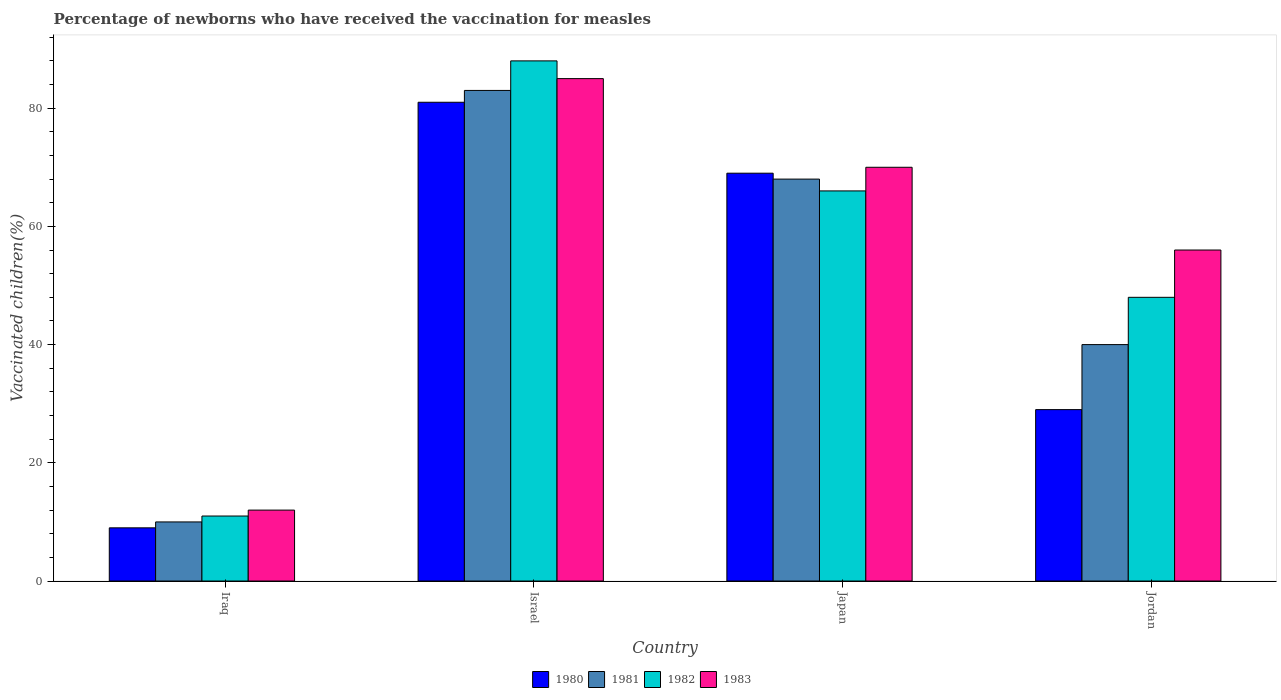How many different coloured bars are there?
Offer a very short reply. 4. How many groups of bars are there?
Your answer should be very brief. 4. Are the number of bars on each tick of the X-axis equal?
Give a very brief answer. Yes. In how many cases, is the number of bars for a given country not equal to the number of legend labels?
Provide a succinct answer. 0. In which country was the percentage of vaccinated children in 1983 maximum?
Your response must be concise. Israel. In which country was the percentage of vaccinated children in 1982 minimum?
Offer a terse response. Iraq. What is the total percentage of vaccinated children in 1981 in the graph?
Keep it short and to the point. 201. What is the average percentage of vaccinated children in 1983 per country?
Ensure brevity in your answer.  55.75. What is the difference between the percentage of vaccinated children of/in 1982 and percentage of vaccinated children of/in 1980 in Japan?
Provide a short and direct response. -3. What is the ratio of the percentage of vaccinated children in 1982 in Iraq to that in Israel?
Ensure brevity in your answer.  0.12. What is the difference between the highest and the lowest percentage of vaccinated children in 1980?
Provide a short and direct response. 72. In how many countries, is the percentage of vaccinated children in 1983 greater than the average percentage of vaccinated children in 1983 taken over all countries?
Your answer should be very brief. 3. Is it the case that in every country, the sum of the percentage of vaccinated children in 1983 and percentage of vaccinated children in 1982 is greater than the sum of percentage of vaccinated children in 1981 and percentage of vaccinated children in 1980?
Give a very brief answer. No. What does the 4th bar from the right in Israel represents?
Provide a succinct answer. 1980. Where does the legend appear in the graph?
Make the answer very short. Bottom center. How many legend labels are there?
Give a very brief answer. 4. How are the legend labels stacked?
Provide a short and direct response. Horizontal. What is the title of the graph?
Provide a succinct answer. Percentage of newborns who have received the vaccination for measles. Does "2003" appear as one of the legend labels in the graph?
Provide a succinct answer. No. What is the label or title of the X-axis?
Provide a succinct answer. Country. What is the label or title of the Y-axis?
Offer a very short reply. Vaccinated children(%). What is the Vaccinated children(%) of 1980 in Iraq?
Your answer should be compact. 9. What is the Vaccinated children(%) in 1982 in Iraq?
Make the answer very short. 11. What is the Vaccinated children(%) in 1983 in Iraq?
Offer a terse response. 12. What is the Vaccinated children(%) in 1980 in Israel?
Keep it short and to the point. 81. What is the Vaccinated children(%) of 1981 in Israel?
Give a very brief answer. 83. What is the Vaccinated children(%) of 1980 in Japan?
Make the answer very short. 69. What is the Vaccinated children(%) of 1980 in Jordan?
Provide a short and direct response. 29. What is the Vaccinated children(%) in 1981 in Jordan?
Your response must be concise. 40. Across all countries, what is the maximum Vaccinated children(%) in 1980?
Provide a short and direct response. 81. Across all countries, what is the maximum Vaccinated children(%) of 1981?
Ensure brevity in your answer.  83. Across all countries, what is the maximum Vaccinated children(%) of 1983?
Your response must be concise. 85. Across all countries, what is the minimum Vaccinated children(%) of 1980?
Provide a succinct answer. 9. Across all countries, what is the minimum Vaccinated children(%) in 1981?
Ensure brevity in your answer.  10. Across all countries, what is the minimum Vaccinated children(%) in 1982?
Offer a very short reply. 11. Across all countries, what is the minimum Vaccinated children(%) of 1983?
Provide a succinct answer. 12. What is the total Vaccinated children(%) of 1980 in the graph?
Ensure brevity in your answer.  188. What is the total Vaccinated children(%) in 1981 in the graph?
Keep it short and to the point. 201. What is the total Vaccinated children(%) of 1982 in the graph?
Your answer should be very brief. 213. What is the total Vaccinated children(%) in 1983 in the graph?
Ensure brevity in your answer.  223. What is the difference between the Vaccinated children(%) of 1980 in Iraq and that in Israel?
Provide a short and direct response. -72. What is the difference between the Vaccinated children(%) of 1981 in Iraq and that in Israel?
Your response must be concise. -73. What is the difference between the Vaccinated children(%) in 1982 in Iraq and that in Israel?
Your response must be concise. -77. What is the difference between the Vaccinated children(%) in 1983 in Iraq and that in Israel?
Offer a terse response. -73. What is the difference between the Vaccinated children(%) of 1980 in Iraq and that in Japan?
Offer a very short reply. -60. What is the difference between the Vaccinated children(%) in 1981 in Iraq and that in Japan?
Your answer should be very brief. -58. What is the difference between the Vaccinated children(%) of 1982 in Iraq and that in Japan?
Make the answer very short. -55. What is the difference between the Vaccinated children(%) of 1983 in Iraq and that in Japan?
Keep it short and to the point. -58. What is the difference between the Vaccinated children(%) in 1982 in Iraq and that in Jordan?
Provide a succinct answer. -37. What is the difference between the Vaccinated children(%) of 1983 in Iraq and that in Jordan?
Your answer should be compact. -44. What is the difference between the Vaccinated children(%) of 1981 in Israel and that in Japan?
Make the answer very short. 15. What is the difference between the Vaccinated children(%) in 1980 in Israel and that in Jordan?
Keep it short and to the point. 52. What is the difference between the Vaccinated children(%) in 1980 in Japan and that in Jordan?
Your answer should be very brief. 40. What is the difference between the Vaccinated children(%) of 1981 in Japan and that in Jordan?
Offer a very short reply. 28. What is the difference between the Vaccinated children(%) of 1982 in Japan and that in Jordan?
Give a very brief answer. 18. What is the difference between the Vaccinated children(%) in 1980 in Iraq and the Vaccinated children(%) in 1981 in Israel?
Provide a succinct answer. -74. What is the difference between the Vaccinated children(%) of 1980 in Iraq and the Vaccinated children(%) of 1982 in Israel?
Provide a short and direct response. -79. What is the difference between the Vaccinated children(%) of 1980 in Iraq and the Vaccinated children(%) of 1983 in Israel?
Your answer should be very brief. -76. What is the difference between the Vaccinated children(%) in 1981 in Iraq and the Vaccinated children(%) in 1982 in Israel?
Offer a terse response. -78. What is the difference between the Vaccinated children(%) in 1981 in Iraq and the Vaccinated children(%) in 1983 in Israel?
Ensure brevity in your answer.  -75. What is the difference between the Vaccinated children(%) of 1982 in Iraq and the Vaccinated children(%) of 1983 in Israel?
Your response must be concise. -74. What is the difference between the Vaccinated children(%) in 1980 in Iraq and the Vaccinated children(%) in 1981 in Japan?
Offer a terse response. -59. What is the difference between the Vaccinated children(%) in 1980 in Iraq and the Vaccinated children(%) in 1982 in Japan?
Your response must be concise. -57. What is the difference between the Vaccinated children(%) in 1980 in Iraq and the Vaccinated children(%) in 1983 in Japan?
Make the answer very short. -61. What is the difference between the Vaccinated children(%) in 1981 in Iraq and the Vaccinated children(%) in 1982 in Japan?
Your answer should be compact. -56. What is the difference between the Vaccinated children(%) of 1981 in Iraq and the Vaccinated children(%) of 1983 in Japan?
Give a very brief answer. -60. What is the difference between the Vaccinated children(%) of 1982 in Iraq and the Vaccinated children(%) of 1983 in Japan?
Provide a short and direct response. -59. What is the difference between the Vaccinated children(%) in 1980 in Iraq and the Vaccinated children(%) in 1981 in Jordan?
Ensure brevity in your answer.  -31. What is the difference between the Vaccinated children(%) in 1980 in Iraq and the Vaccinated children(%) in 1982 in Jordan?
Your response must be concise. -39. What is the difference between the Vaccinated children(%) of 1980 in Iraq and the Vaccinated children(%) of 1983 in Jordan?
Your response must be concise. -47. What is the difference between the Vaccinated children(%) of 1981 in Iraq and the Vaccinated children(%) of 1982 in Jordan?
Your response must be concise. -38. What is the difference between the Vaccinated children(%) of 1981 in Iraq and the Vaccinated children(%) of 1983 in Jordan?
Provide a succinct answer. -46. What is the difference between the Vaccinated children(%) in 1982 in Iraq and the Vaccinated children(%) in 1983 in Jordan?
Ensure brevity in your answer.  -45. What is the difference between the Vaccinated children(%) in 1982 in Israel and the Vaccinated children(%) in 1983 in Japan?
Ensure brevity in your answer.  18. What is the difference between the Vaccinated children(%) of 1980 in Israel and the Vaccinated children(%) of 1981 in Jordan?
Offer a very short reply. 41. What is the difference between the Vaccinated children(%) of 1980 in Israel and the Vaccinated children(%) of 1982 in Jordan?
Ensure brevity in your answer.  33. What is the difference between the Vaccinated children(%) in 1980 in Israel and the Vaccinated children(%) in 1983 in Jordan?
Offer a very short reply. 25. What is the difference between the Vaccinated children(%) in 1981 in Israel and the Vaccinated children(%) in 1983 in Jordan?
Your response must be concise. 27. What is the difference between the Vaccinated children(%) in 1982 in Israel and the Vaccinated children(%) in 1983 in Jordan?
Provide a short and direct response. 32. What is the difference between the Vaccinated children(%) of 1980 in Japan and the Vaccinated children(%) of 1982 in Jordan?
Provide a succinct answer. 21. What is the difference between the Vaccinated children(%) of 1980 in Japan and the Vaccinated children(%) of 1983 in Jordan?
Your response must be concise. 13. What is the difference between the Vaccinated children(%) of 1982 in Japan and the Vaccinated children(%) of 1983 in Jordan?
Give a very brief answer. 10. What is the average Vaccinated children(%) in 1980 per country?
Make the answer very short. 47. What is the average Vaccinated children(%) in 1981 per country?
Ensure brevity in your answer.  50.25. What is the average Vaccinated children(%) in 1982 per country?
Keep it short and to the point. 53.25. What is the average Vaccinated children(%) in 1983 per country?
Give a very brief answer. 55.75. What is the difference between the Vaccinated children(%) in 1980 and Vaccinated children(%) in 1982 in Iraq?
Keep it short and to the point. -2. What is the difference between the Vaccinated children(%) in 1980 and Vaccinated children(%) in 1983 in Iraq?
Ensure brevity in your answer.  -3. What is the difference between the Vaccinated children(%) in 1981 and Vaccinated children(%) in 1982 in Iraq?
Ensure brevity in your answer.  -1. What is the difference between the Vaccinated children(%) of 1981 and Vaccinated children(%) of 1983 in Iraq?
Your response must be concise. -2. What is the difference between the Vaccinated children(%) of 1982 and Vaccinated children(%) of 1983 in Iraq?
Give a very brief answer. -1. What is the difference between the Vaccinated children(%) of 1980 and Vaccinated children(%) of 1981 in Israel?
Your answer should be very brief. -2. What is the difference between the Vaccinated children(%) in 1980 and Vaccinated children(%) in 1983 in Israel?
Make the answer very short. -4. What is the difference between the Vaccinated children(%) in 1981 and Vaccinated children(%) in 1983 in Israel?
Keep it short and to the point. -2. What is the difference between the Vaccinated children(%) in 1982 and Vaccinated children(%) in 1983 in Israel?
Give a very brief answer. 3. What is the difference between the Vaccinated children(%) of 1980 and Vaccinated children(%) of 1982 in Japan?
Give a very brief answer. 3. What is the difference between the Vaccinated children(%) of 1980 and Vaccinated children(%) of 1983 in Japan?
Make the answer very short. -1. What is the difference between the Vaccinated children(%) of 1982 and Vaccinated children(%) of 1983 in Japan?
Provide a succinct answer. -4. What is the difference between the Vaccinated children(%) in 1980 and Vaccinated children(%) in 1981 in Jordan?
Ensure brevity in your answer.  -11. What is the difference between the Vaccinated children(%) of 1980 and Vaccinated children(%) of 1982 in Jordan?
Ensure brevity in your answer.  -19. What is the difference between the Vaccinated children(%) in 1981 and Vaccinated children(%) in 1982 in Jordan?
Offer a terse response. -8. What is the ratio of the Vaccinated children(%) of 1981 in Iraq to that in Israel?
Provide a short and direct response. 0.12. What is the ratio of the Vaccinated children(%) in 1983 in Iraq to that in Israel?
Ensure brevity in your answer.  0.14. What is the ratio of the Vaccinated children(%) of 1980 in Iraq to that in Japan?
Provide a short and direct response. 0.13. What is the ratio of the Vaccinated children(%) of 1981 in Iraq to that in Japan?
Keep it short and to the point. 0.15. What is the ratio of the Vaccinated children(%) in 1982 in Iraq to that in Japan?
Keep it short and to the point. 0.17. What is the ratio of the Vaccinated children(%) in 1983 in Iraq to that in Japan?
Your answer should be very brief. 0.17. What is the ratio of the Vaccinated children(%) in 1980 in Iraq to that in Jordan?
Provide a succinct answer. 0.31. What is the ratio of the Vaccinated children(%) of 1981 in Iraq to that in Jordan?
Give a very brief answer. 0.25. What is the ratio of the Vaccinated children(%) in 1982 in Iraq to that in Jordan?
Your response must be concise. 0.23. What is the ratio of the Vaccinated children(%) of 1983 in Iraq to that in Jordan?
Keep it short and to the point. 0.21. What is the ratio of the Vaccinated children(%) of 1980 in Israel to that in Japan?
Keep it short and to the point. 1.17. What is the ratio of the Vaccinated children(%) of 1981 in Israel to that in Japan?
Your answer should be very brief. 1.22. What is the ratio of the Vaccinated children(%) of 1982 in Israel to that in Japan?
Make the answer very short. 1.33. What is the ratio of the Vaccinated children(%) of 1983 in Israel to that in Japan?
Offer a very short reply. 1.21. What is the ratio of the Vaccinated children(%) in 1980 in Israel to that in Jordan?
Your answer should be very brief. 2.79. What is the ratio of the Vaccinated children(%) of 1981 in Israel to that in Jordan?
Your response must be concise. 2.08. What is the ratio of the Vaccinated children(%) of 1982 in Israel to that in Jordan?
Give a very brief answer. 1.83. What is the ratio of the Vaccinated children(%) in 1983 in Israel to that in Jordan?
Provide a succinct answer. 1.52. What is the ratio of the Vaccinated children(%) of 1980 in Japan to that in Jordan?
Offer a very short reply. 2.38. What is the ratio of the Vaccinated children(%) in 1981 in Japan to that in Jordan?
Give a very brief answer. 1.7. What is the ratio of the Vaccinated children(%) of 1982 in Japan to that in Jordan?
Offer a very short reply. 1.38. What is the ratio of the Vaccinated children(%) of 1983 in Japan to that in Jordan?
Provide a short and direct response. 1.25. What is the difference between the highest and the second highest Vaccinated children(%) in 1980?
Your answer should be very brief. 12. What is the difference between the highest and the second highest Vaccinated children(%) in 1983?
Keep it short and to the point. 15. What is the difference between the highest and the lowest Vaccinated children(%) of 1981?
Ensure brevity in your answer.  73. What is the difference between the highest and the lowest Vaccinated children(%) of 1983?
Your answer should be compact. 73. 